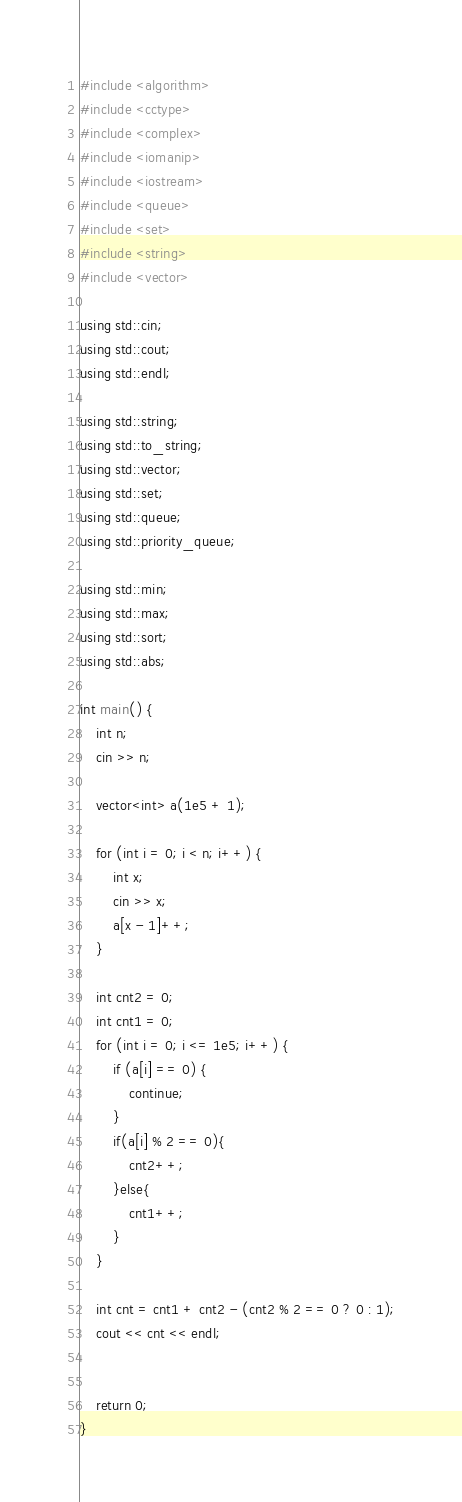Convert code to text. <code><loc_0><loc_0><loc_500><loc_500><_C++_>#include <algorithm>
#include <cctype>
#include <complex>
#include <iomanip>
#include <iostream>
#include <queue>
#include <set>
#include <string>
#include <vector>

using std::cin;
using std::cout;
using std::endl;

using std::string;
using std::to_string;
using std::vector;
using std::set;
using std::queue;
using std::priority_queue;

using std::min;
using std::max;
using std::sort;
using std::abs;

int main() {
    int n;
    cin >> n;

    vector<int> a(1e5 + 1);

    for (int i = 0; i < n; i++) {
        int x;
        cin >> x;
        a[x - 1]++;
    }

    int cnt2 = 0;
    int cnt1 = 0;
    for (int i = 0; i <= 1e5; i++) {
        if (a[i] == 0) {
            continue;
        }
        if(a[i] % 2 == 0){
            cnt2++;
        }else{
            cnt1++;
        }
    }

    int cnt = cnt1 + cnt2 - (cnt2 % 2 == 0 ? 0 : 1);
    cout << cnt << endl;


    return 0;
}

</code> 